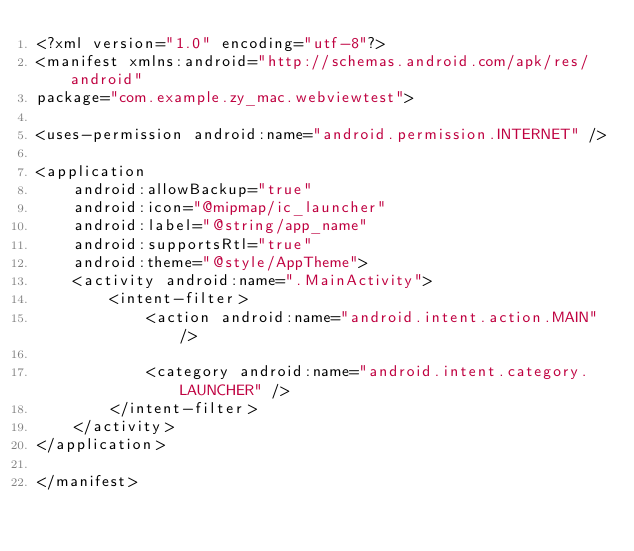Convert code to text. <code><loc_0><loc_0><loc_500><loc_500><_XML_><?xml version="1.0" encoding="utf-8"?>
<manifest xmlns:android="http://schemas.android.com/apk/res/android"
package="com.example.zy_mac.webviewtest">

<uses-permission android:name="android.permission.INTERNET" />

<application
    android:allowBackup="true"
    android:icon="@mipmap/ic_launcher"
    android:label="@string/app_name"
    android:supportsRtl="true"
    android:theme="@style/AppTheme">
    <activity android:name=".MainActivity">
        <intent-filter>
            <action android:name="android.intent.action.MAIN" />

            <category android:name="android.intent.category.LAUNCHER" />
        </intent-filter>
    </activity>
</application>

</manifest></code> 